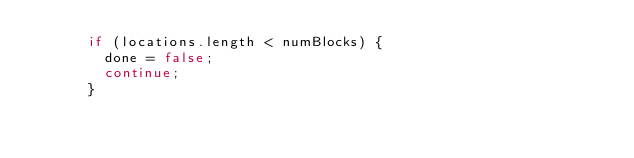<code> <loc_0><loc_0><loc_500><loc_500><_Java_>      if (locations.length < numBlocks) {
        done = false;
        continue;
      }</code> 